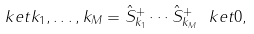<formula> <loc_0><loc_0><loc_500><loc_500>\ k e t { k _ { 1 } , \dots , k _ { M } } = \hat { S } _ { k _ { 1 } } ^ { + } \cdots \hat { S } _ { k _ { M } } ^ { + } \ k e t { 0 } ,</formula> 